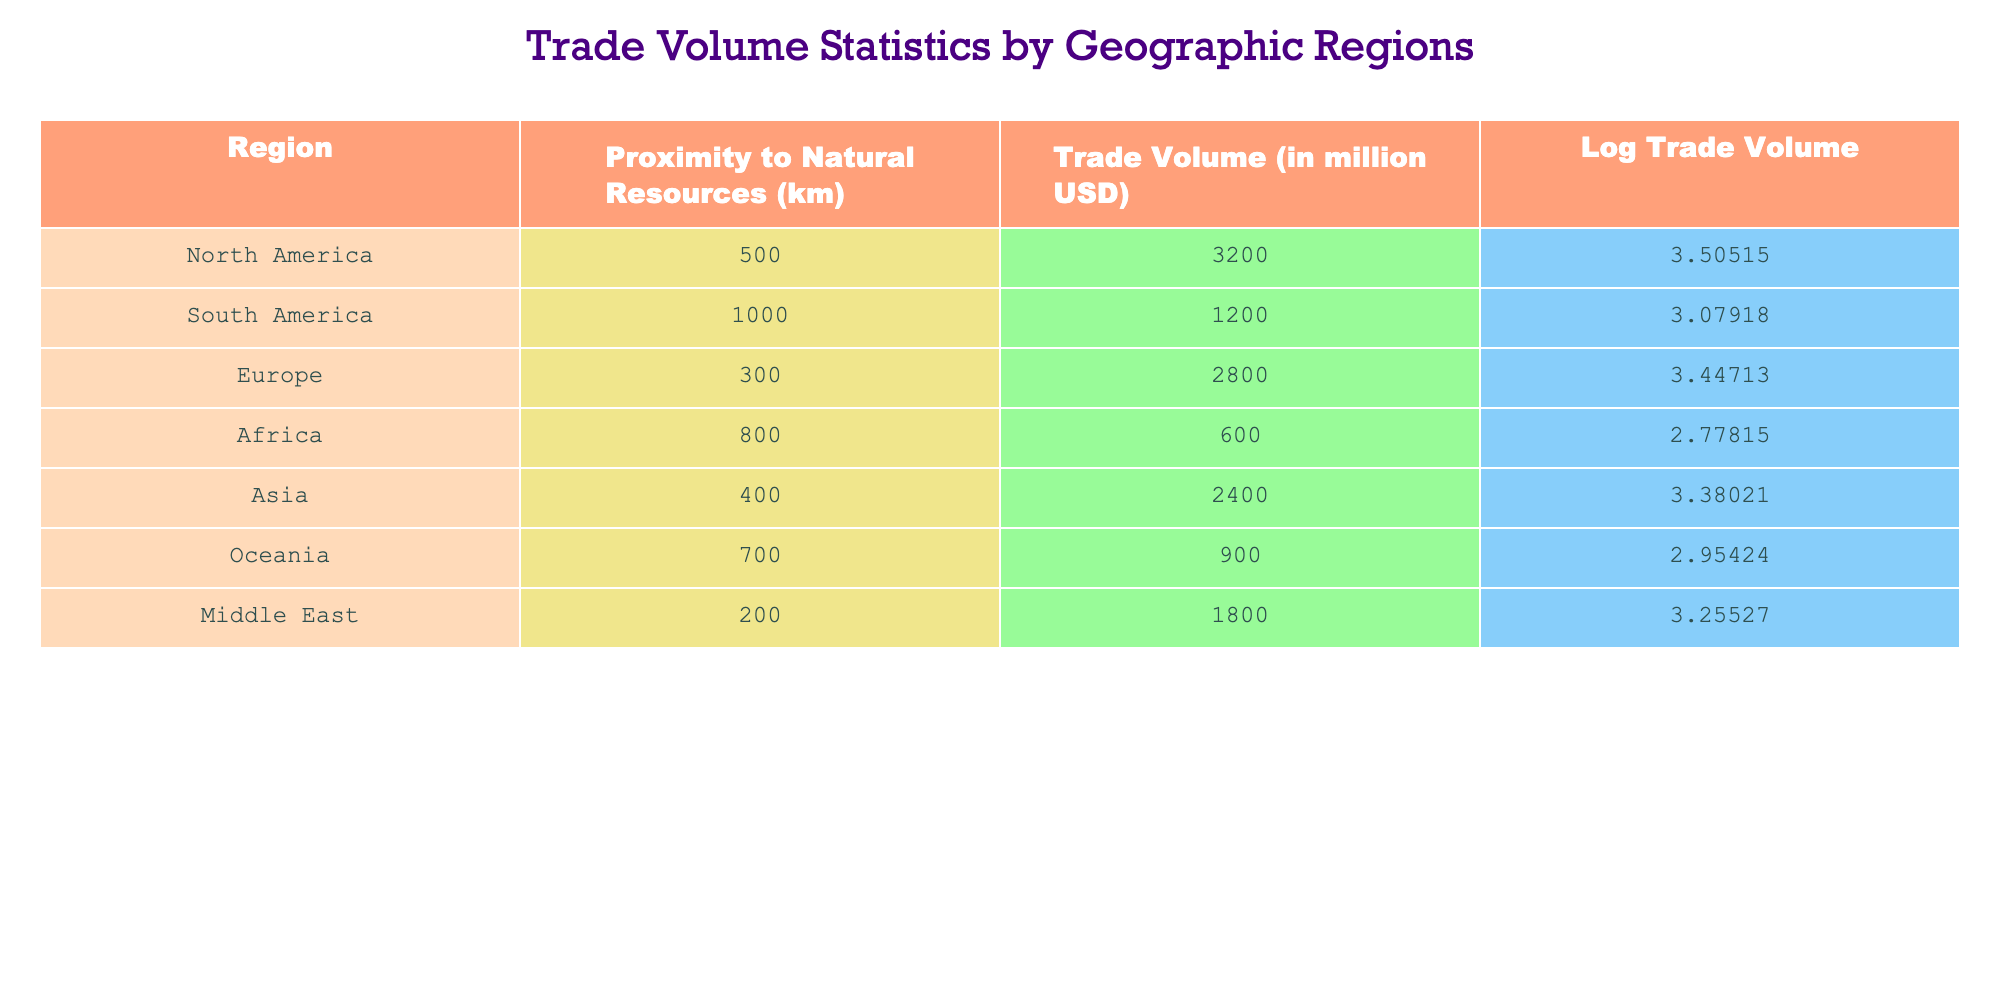What is the trade volume for Europe? The trade volume for Europe is listed directly in the table under the column "Trade Volume". Referring to the row for Europe, the value is 2800 million USD.
Answer: 2800 million USD Which region has the highest log trade volume? To answer this, we reference the "Log Trade Volume" column and compare the values for all regions. North America has the highest value of 3.50515.
Answer: North America What is the average trade volume for regions within 500 km of natural resources? We first identify the regions with a proximity to natural resources of 500 km or less, which are North America (3200), Europe (2800), and the Middle East (1800). Adding these values gives 3200 + 2800 + 1800 = 7800. There are three regions, so the average is 7800 / 3 = 2600.
Answer: 2600 million USD Is the trade volume for Africa greater than that of Asia? Comparing the trade volume for Africa (600 million USD) and Asia (2400 million USD), we see that 600 is less than 2400. Thus, the statement is false.
Answer: No What is the total trade volume for regions with over 1000 km proximity to natural resources? First, identify the regions with over 1000 km proximity: South America (1200) and Oceania (900). Adding these values gives 1200 + 900 = 2100.
Answer: 2100 million USD Which region in the table has the closest proximity to natural resources? Examining the "Proximity to Natural Resources" column, we find that Africa has the closest proximity at 800 km.
Answer: Africa Is the log trade volume for Oceania more than that for South America? The log trade volume for Oceania is 2.95424, and for South America, it is 3.07918. Since 2.95424 is less than 3.07918, the statement is false.
Answer: No What is the difference in trade volume between North America and Africa? The trade volume for North America is 3200 million USD and for Africa is 600 million USD. The difference is 3200 - 600 = 2600 million USD.
Answer: 2600 million USD How many regions have a trade volume greater than 2000 million USD? The regions with trade volumes greater than 2000 million USD are North America (3200), Europe (2800), and Asia (2400). Counting these gives us three regions.
Answer: 3 